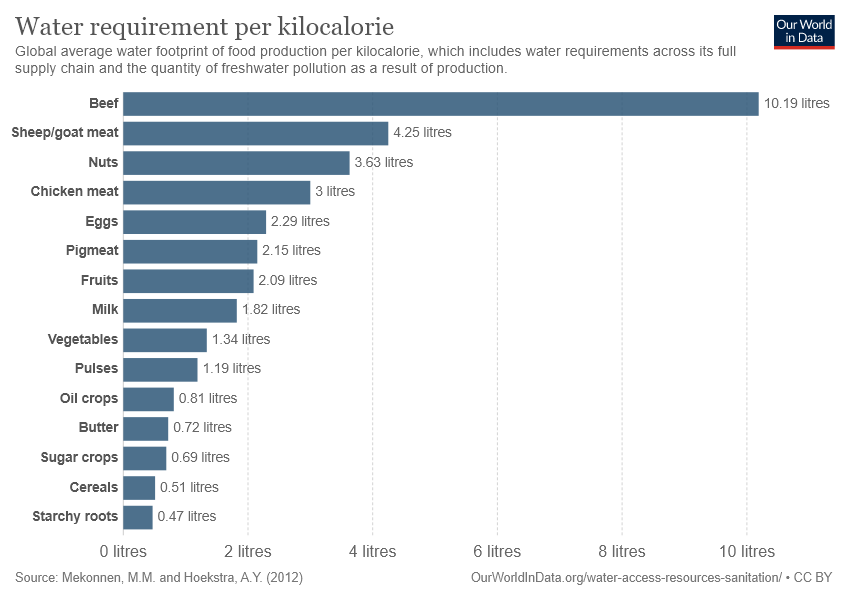Point out several critical features in this image. Of the food items, how many have a water requirement of less than 1 liter? The crop with the highest water requirement is 10.19... 